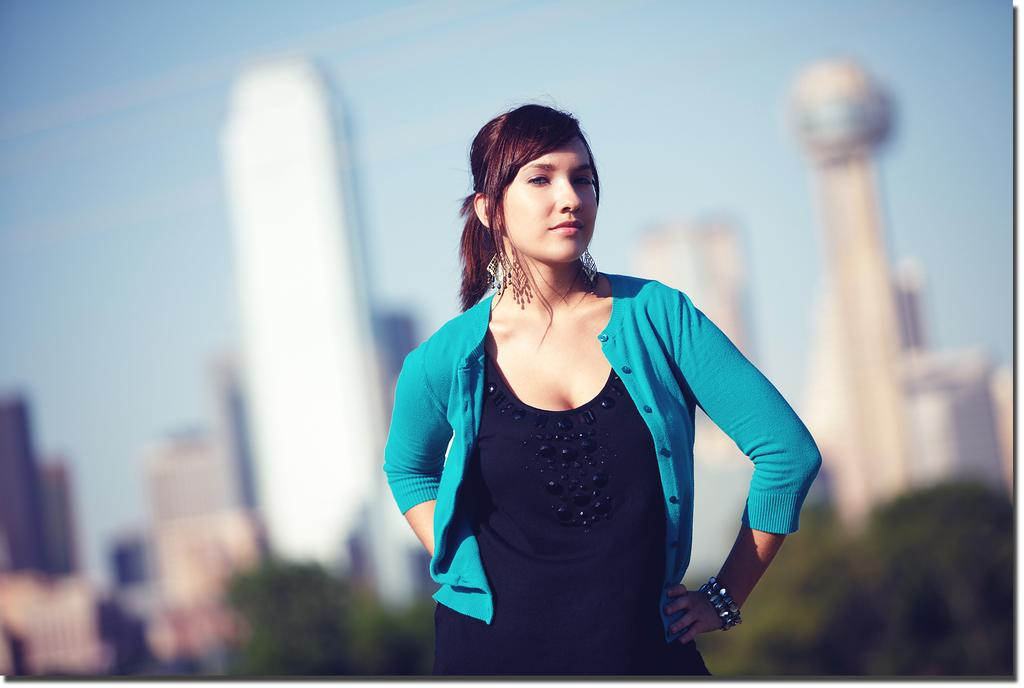What is the main subject of the image? There is a lady standing in the center of the image. What can be seen in the background of the image? There are buildings, trees, and the sky visible in the background of the image. What type of tin is being used by the lady in the image? There is no tin present in the image; the lady is simply standing in the center. 